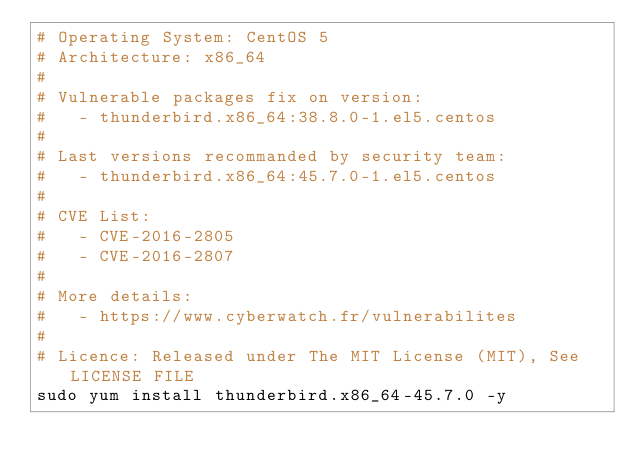<code> <loc_0><loc_0><loc_500><loc_500><_Bash_># Operating System: CentOS 5
# Architecture: x86_64
#
# Vulnerable packages fix on version:
#   - thunderbird.x86_64:38.8.0-1.el5.centos
#
# Last versions recommanded by security team:
#   - thunderbird.x86_64:45.7.0-1.el5.centos
#
# CVE List:
#   - CVE-2016-2805
#   - CVE-2016-2807
#
# More details:
#   - https://www.cyberwatch.fr/vulnerabilites
#
# Licence: Released under The MIT License (MIT), See LICENSE FILE
sudo yum install thunderbird.x86_64-45.7.0 -y 
</code> 